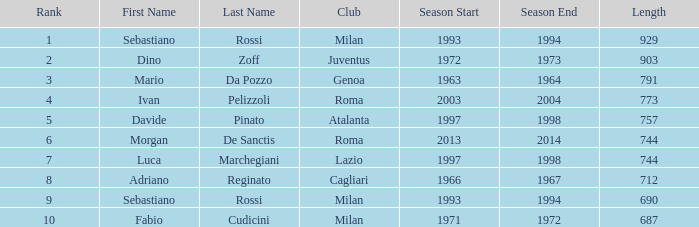What is the name for a length exceeding 903? Sebastiano Rossi. 